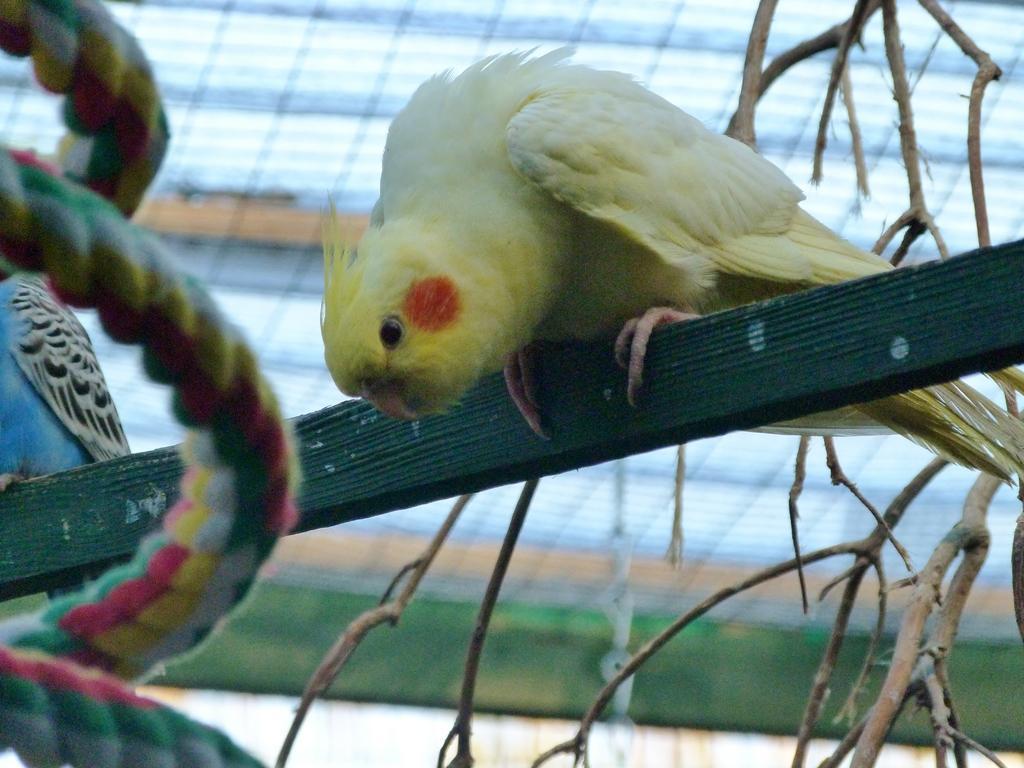Could you give a brief overview of what you see in this image? In this image, we can see birds on the wood stick and there is a rope and we can see a stem. 